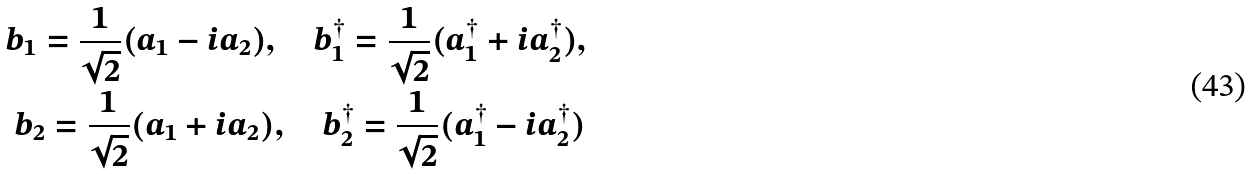Convert formula to latex. <formula><loc_0><loc_0><loc_500><loc_500>b _ { 1 } = \frac { 1 } { \sqrt { 2 } } ( a _ { 1 } - i a _ { 2 } ) , \quad b ^ { \dagger } _ { 1 } = \frac { 1 } { \sqrt { 2 } } ( a ^ { \dagger } _ { 1 } + i a ^ { \dagger } _ { 2 } ) , \\ b _ { 2 } = \frac { 1 } { \sqrt { 2 } } ( a _ { 1 } + i a _ { 2 } ) , \quad b ^ { \dagger } _ { 2 } = \frac { 1 } { \sqrt { 2 } } ( a ^ { \dagger } _ { 1 } - i a ^ { \dagger } _ { 2 } )</formula> 